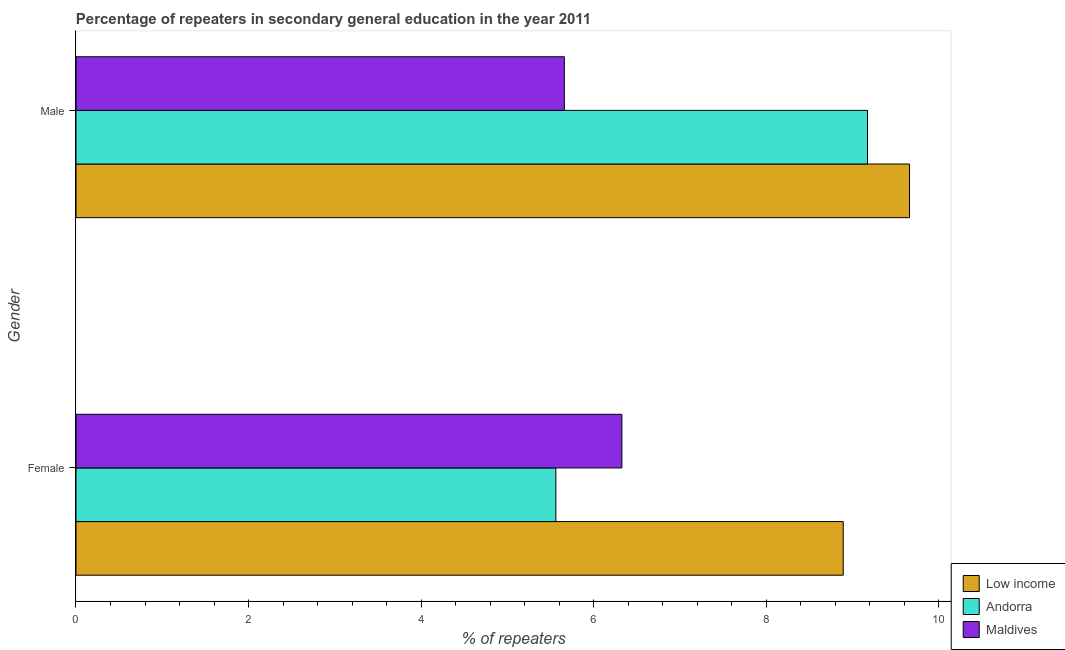Are the number of bars on each tick of the Y-axis equal?
Your answer should be compact. Yes. How many bars are there on the 2nd tick from the bottom?
Make the answer very short. 3. What is the label of the 2nd group of bars from the top?
Make the answer very short. Female. What is the percentage of female repeaters in Maldives?
Your response must be concise. 6.33. Across all countries, what is the maximum percentage of male repeaters?
Ensure brevity in your answer.  9.66. Across all countries, what is the minimum percentage of female repeaters?
Offer a terse response. 5.56. In which country was the percentage of male repeaters minimum?
Make the answer very short. Maldives. What is the total percentage of male repeaters in the graph?
Give a very brief answer. 24.5. What is the difference between the percentage of female repeaters in Maldives and that in Low income?
Your answer should be compact. -2.57. What is the difference between the percentage of male repeaters in Low income and the percentage of female repeaters in Andorra?
Give a very brief answer. 4.1. What is the average percentage of male repeaters per country?
Provide a short and direct response. 8.17. What is the difference between the percentage of male repeaters and percentage of female repeaters in Maldives?
Your answer should be compact. -0.67. What is the ratio of the percentage of female repeaters in Andorra to that in Maldives?
Keep it short and to the point. 0.88. What does the 2nd bar from the top in Male represents?
Offer a very short reply. Andorra. Are all the bars in the graph horizontal?
Ensure brevity in your answer.  Yes. Are the values on the major ticks of X-axis written in scientific E-notation?
Provide a short and direct response. No. Where does the legend appear in the graph?
Make the answer very short. Bottom right. How are the legend labels stacked?
Make the answer very short. Vertical. What is the title of the graph?
Make the answer very short. Percentage of repeaters in secondary general education in the year 2011. What is the label or title of the X-axis?
Ensure brevity in your answer.  % of repeaters. What is the label or title of the Y-axis?
Keep it short and to the point. Gender. What is the % of repeaters in Low income in Female?
Give a very brief answer. 8.89. What is the % of repeaters in Andorra in Female?
Provide a short and direct response. 5.56. What is the % of repeaters in Maldives in Female?
Make the answer very short. 6.33. What is the % of repeaters of Low income in Male?
Offer a very short reply. 9.66. What is the % of repeaters in Andorra in Male?
Your answer should be compact. 9.17. What is the % of repeaters in Maldives in Male?
Your answer should be very brief. 5.66. Across all Gender, what is the maximum % of repeaters of Low income?
Provide a short and direct response. 9.66. Across all Gender, what is the maximum % of repeaters of Andorra?
Offer a very short reply. 9.17. Across all Gender, what is the maximum % of repeaters of Maldives?
Your response must be concise. 6.33. Across all Gender, what is the minimum % of repeaters of Low income?
Your answer should be very brief. 8.89. Across all Gender, what is the minimum % of repeaters of Andorra?
Provide a short and direct response. 5.56. Across all Gender, what is the minimum % of repeaters of Maldives?
Keep it short and to the point. 5.66. What is the total % of repeaters in Low income in the graph?
Offer a terse response. 18.55. What is the total % of repeaters in Andorra in the graph?
Give a very brief answer. 14.74. What is the total % of repeaters in Maldives in the graph?
Give a very brief answer. 11.99. What is the difference between the % of repeaters of Low income in Female and that in Male?
Your answer should be very brief. -0.77. What is the difference between the % of repeaters in Andorra in Female and that in Male?
Give a very brief answer. -3.61. What is the difference between the % of repeaters in Maldives in Female and that in Male?
Your answer should be very brief. 0.67. What is the difference between the % of repeaters in Low income in Female and the % of repeaters in Andorra in Male?
Offer a very short reply. -0.28. What is the difference between the % of repeaters of Low income in Female and the % of repeaters of Maldives in Male?
Offer a terse response. 3.23. What is the difference between the % of repeaters in Andorra in Female and the % of repeaters in Maldives in Male?
Give a very brief answer. -0.1. What is the average % of repeaters of Low income per Gender?
Your answer should be very brief. 9.28. What is the average % of repeaters of Andorra per Gender?
Your response must be concise. 7.37. What is the average % of repeaters of Maldives per Gender?
Provide a succinct answer. 5.99. What is the difference between the % of repeaters of Low income and % of repeaters of Andorra in Female?
Offer a terse response. 3.33. What is the difference between the % of repeaters of Low income and % of repeaters of Maldives in Female?
Offer a very short reply. 2.57. What is the difference between the % of repeaters of Andorra and % of repeaters of Maldives in Female?
Offer a terse response. -0.77. What is the difference between the % of repeaters of Low income and % of repeaters of Andorra in Male?
Your response must be concise. 0.49. What is the difference between the % of repeaters in Low income and % of repeaters in Maldives in Male?
Make the answer very short. 4. What is the difference between the % of repeaters of Andorra and % of repeaters of Maldives in Male?
Offer a terse response. 3.51. What is the ratio of the % of repeaters in Low income in Female to that in Male?
Provide a succinct answer. 0.92. What is the ratio of the % of repeaters of Andorra in Female to that in Male?
Ensure brevity in your answer.  0.61. What is the ratio of the % of repeaters of Maldives in Female to that in Male?
Keep it short and to the point. 1.12. What is the difference between the highest and the second highest % of repeaters of Low income?
Your answer should be compact. 0.77. What is the difference between the highest and the second highest % of repeaters in Andorra?
Ensure brevity in your answer.  3.61. What is the difference between the highest and the second highest % of repeaters of Maldives?
Keep it short and to the point. 0.67. What is the difference between the highest and the lowest % of repeaters of Low income?
Ensure brevity in your answer.  0.77. What is the difference between the highest and the lowest % of repeaters of Andorra?
Your response must be concise. 3.61. What is the difference between the highest and the lowest % of repeaters in Maldives?
Offer a terse response. 0.67. 